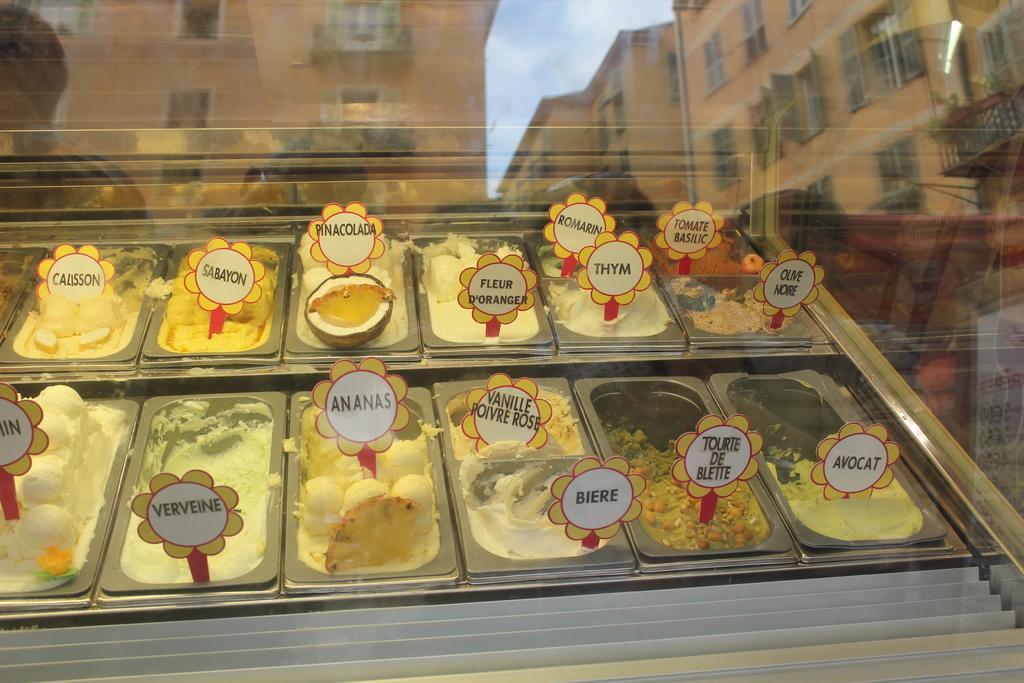Please provide a concise description of this image. This is a glass. Through the glass we can see food items in the container boxes. At the top we can see the reflections of buildings and clouds in the sky. 